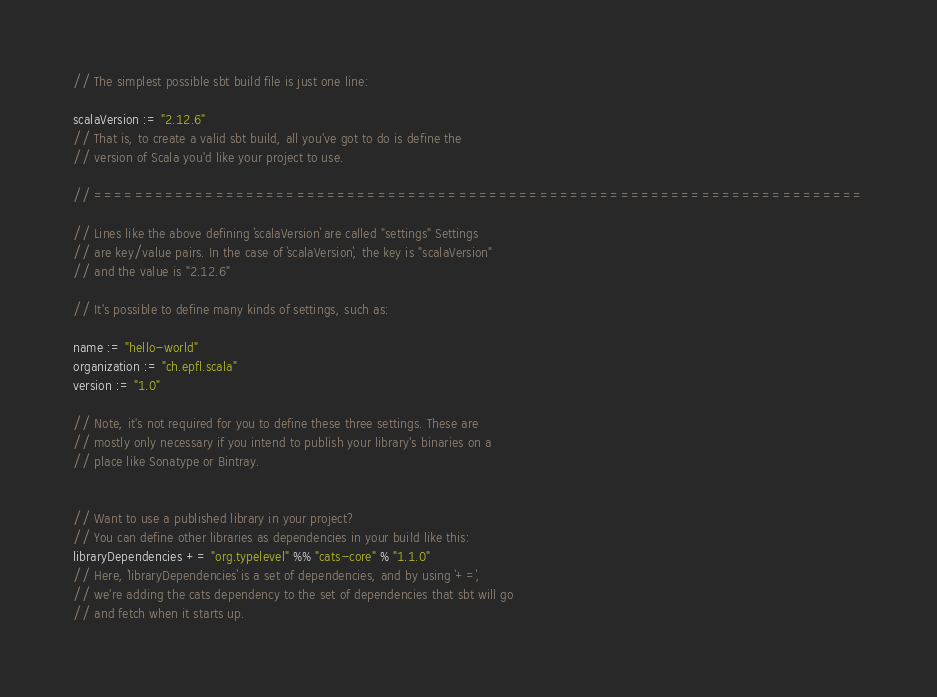Convert code to text. <code><loc_0><loc_0><loc_500><loc_500><_Scala_>
// The simplest possible sbt build file is just one line:

scalaVersion := "2.12.6"
// That is, to create a valid sbt build, all you've got to do is define the
// version of Scala you'd like your project to use.

// ============================================================================

// Lines like the above defining `scalaVersion` are called "settings" Settings
// are key/value pairs. In the case of `scalaVersion`, the key is "scalaVersion"
// and the value is "2.12.6"

// It's possible to define many kinds of settings, such as:

name := "hello-world"
organization := "ch.epfl.scala"
version := "1.0"

// Note, it's not required for you to define these three settings. These are
// mostly only necessary if you intend to publish your library's binaries on a
// place like Sonatype or Bintray.


// Want to use a published library in your project?
// You can define other libraries as dependencies in your build like this:
libraryDependencies += "org.typelevel" %% "cats-core" % "1.1.0"
// Here, `libraryDependencies` is a set of dependencies, and by using `+=`,
// we're adding the cats dependency to the set of dependencies that sbt will go
// and fetch when it starts up.</code> 